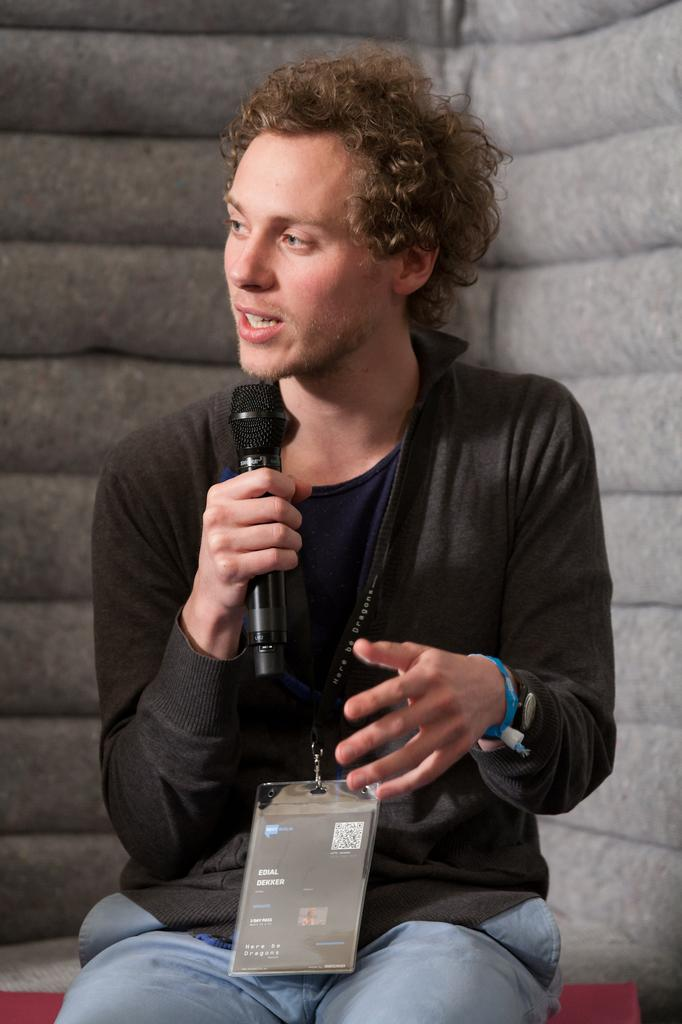Who is the main subject in the image? There is a man in the image. What is the man doing in the image? The man is sitting and speaking. What is the man holding in the image? The man is holding a microphone. What can be seen behind the man in the image? There is a wall behind the man. What type of hook is the man using to hang his head in the image? There is no hook or head present in the image; the man is sitting and speaking while holding a microphone. 